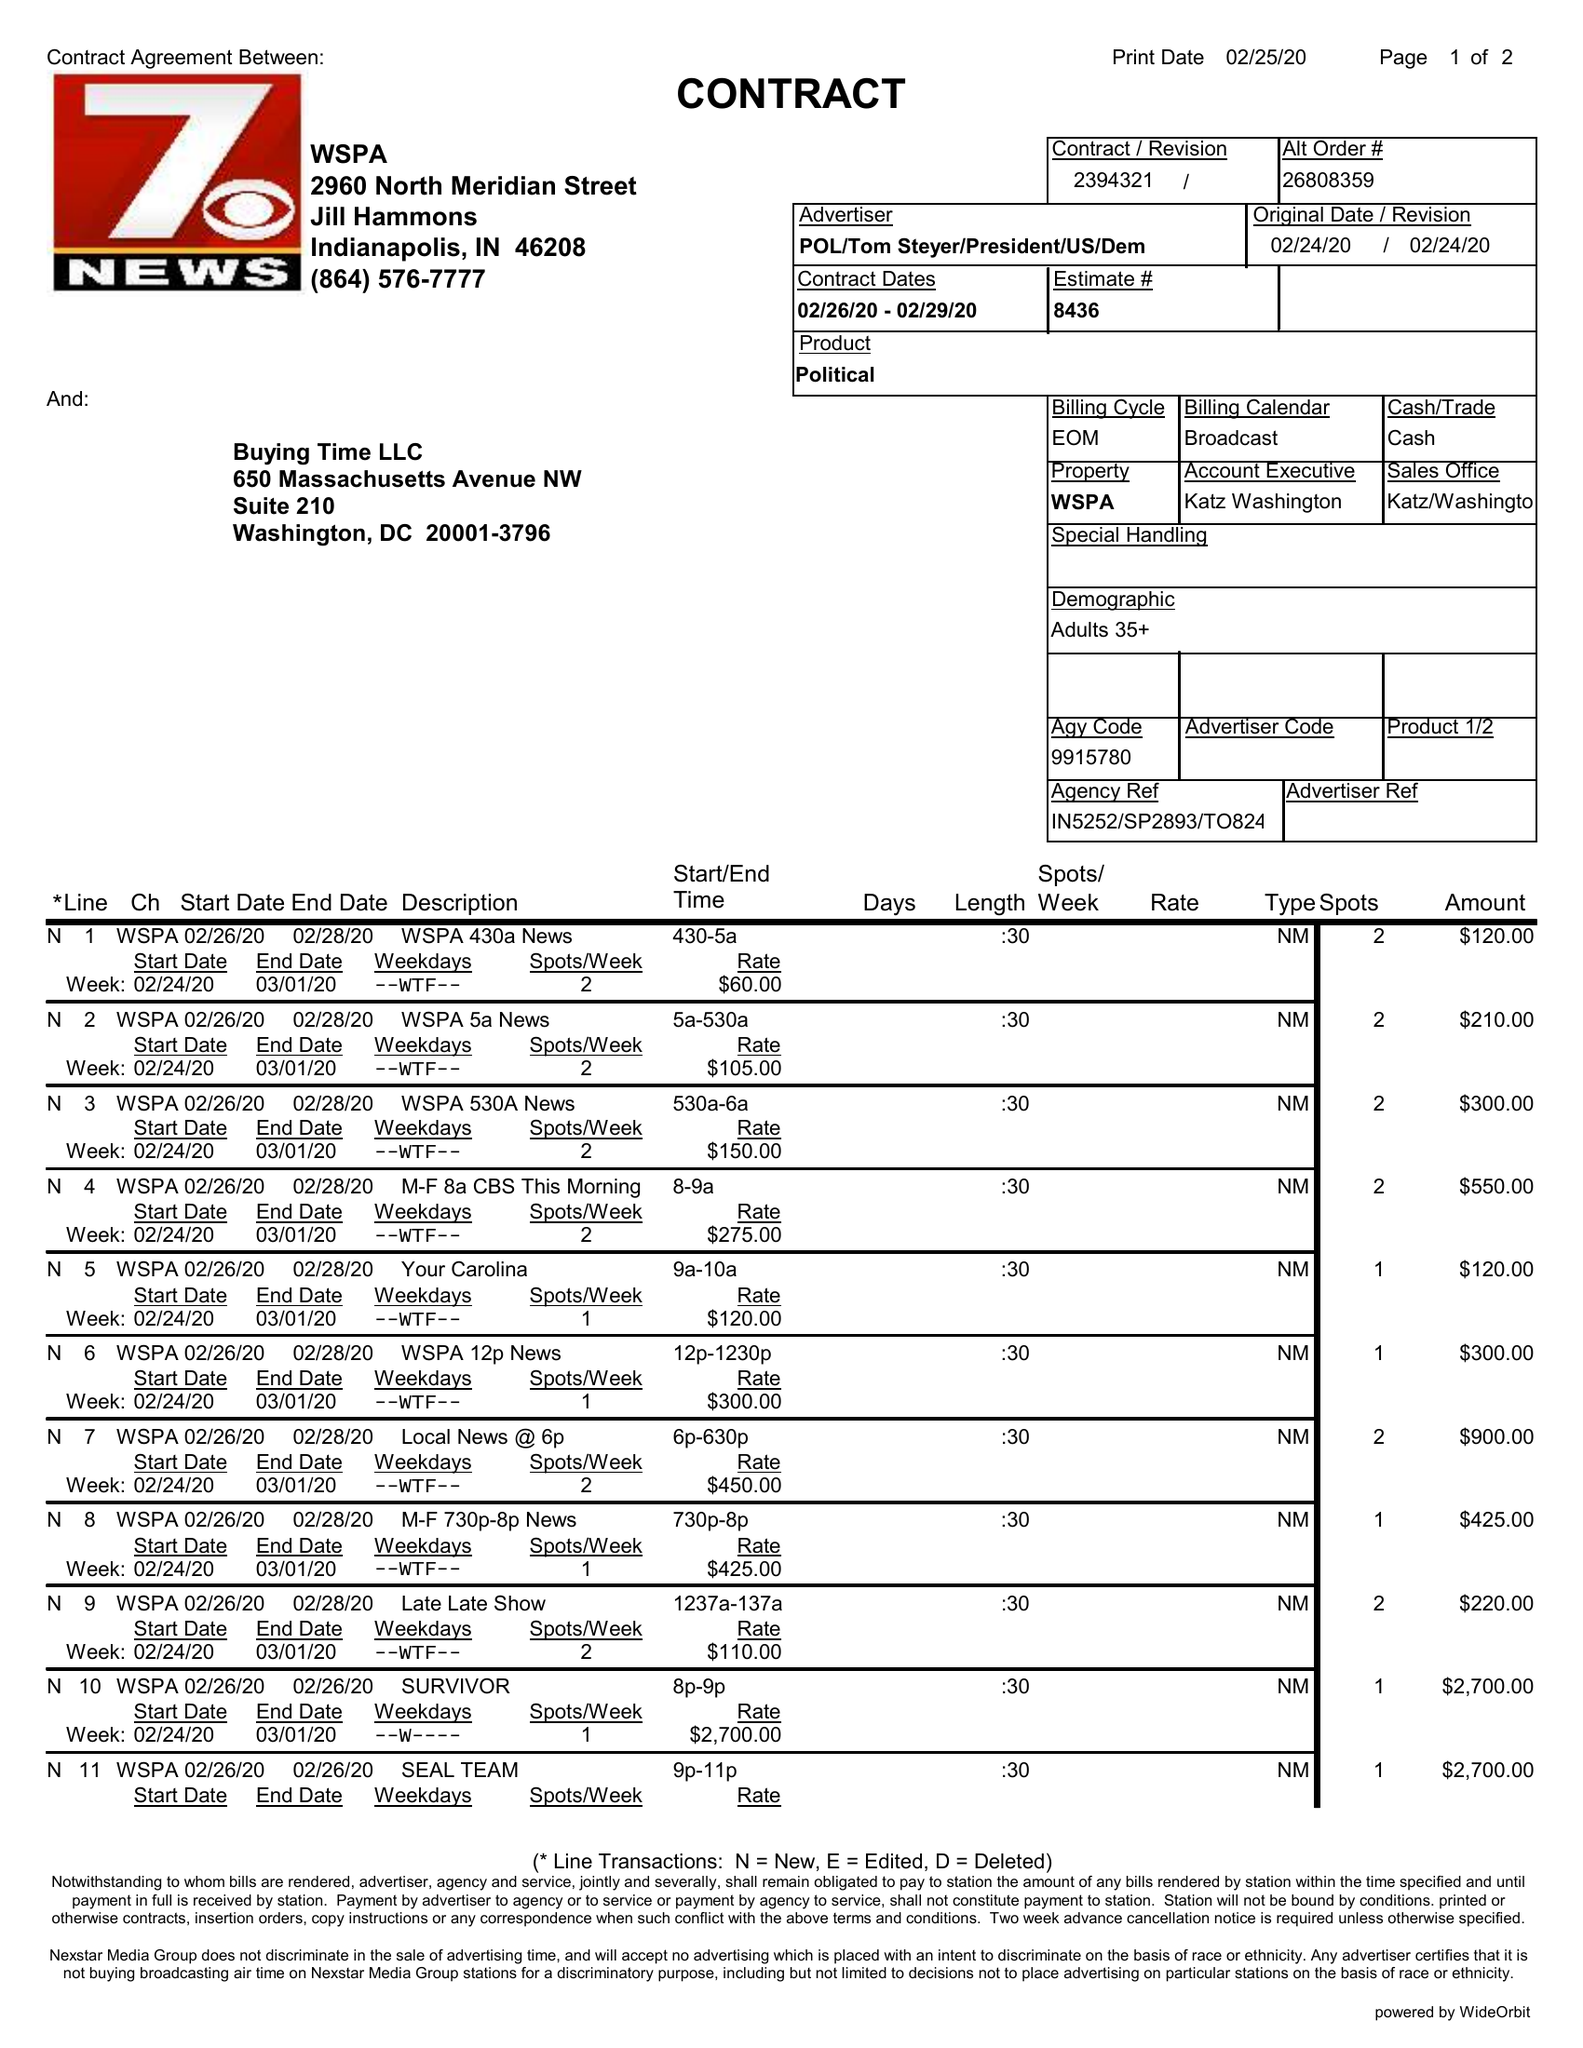What is the value for the flight_to?
Answer the question using a single word or phrase. 02/29/20 